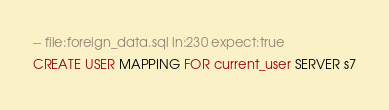<code> <loc_0><loc_0><loc_500><loc_500><_SQL_>-- file:foreign_data.sql ln:230 expect:true
CREATE USER MAPPING FOR current_user SERVER s7
</code> 